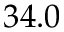Convert formula to latex. <formula><loc_0><loc_0><loc_500><loc_500>3 4 . 0</formula> 